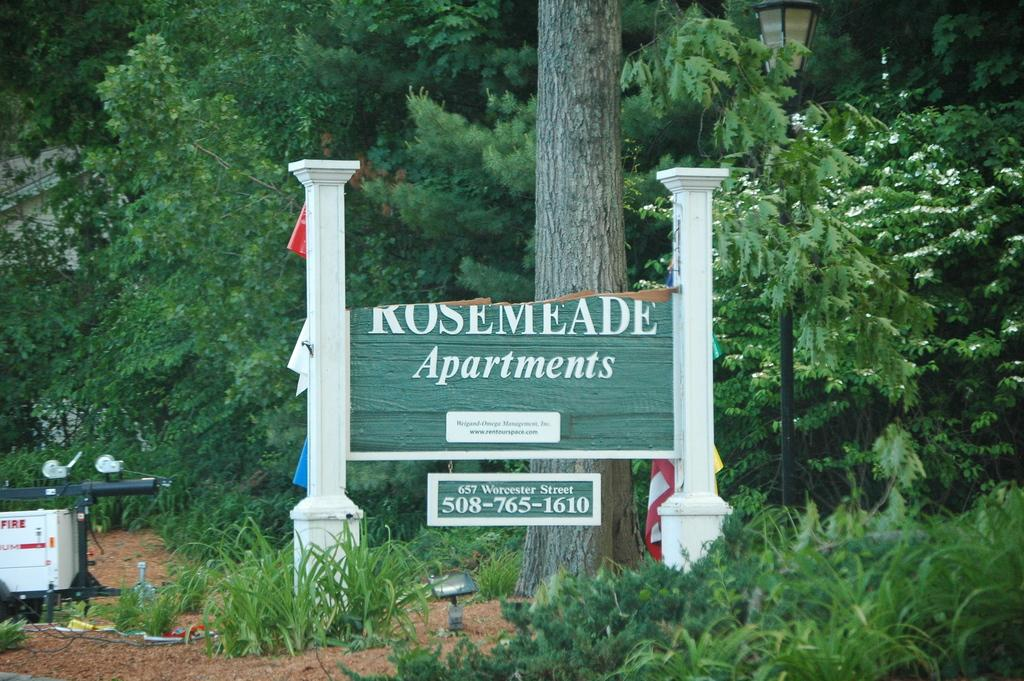What is the main object in the image? There is a board in the image. What is written or displayed on the board? There is text on the board. What can be seen in the background of the image? There are trees and a light pole in the background of the image. Where is the bag hanging from the cart in the image? There is no bag or cart present in the image. How many mittens can be seen on the board in the image? There are no mittens present on the board or in the image. 